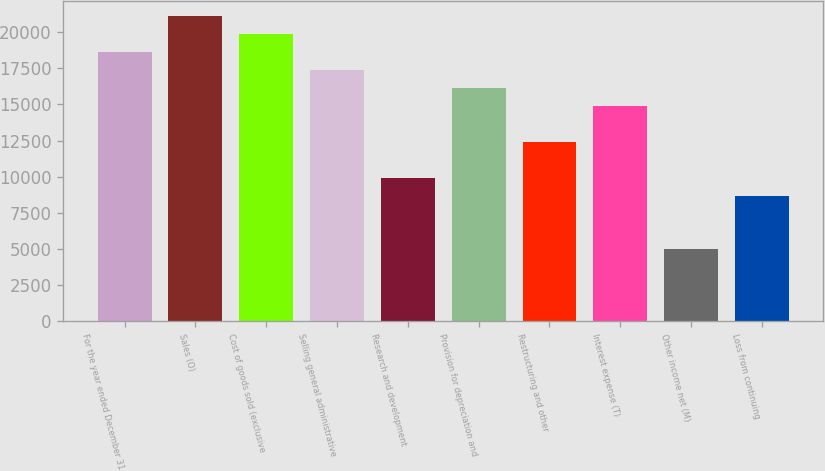Convert chart to OTSL. <chart><loc_0><loc_0><loc_500><loc_500><bar_chart><fcel>For the year ended December 31<fcel>Sales (O)<fcel>Cost of goods sold (exclusive<fcel>Selling general administrative<fcel>Research and development<fcel>Provision for depreciation and<fcel>Restructuring and other<fcel>Interest expense (T)<fcel>Other income net (M)<fcel>Loss from continuing<nl><fcel>18619.3<fcel>21101.8<fcel>19860.5<fcel>17378<fcel>9930.47<fcel>16136.8<fcel>12413<fcel>14895.5<fcel>4965.43<fcel>8689.21<nl></chart> 